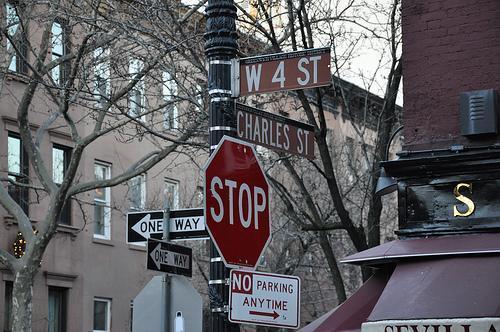How many stop signs are there?
Give a very brief answer. 1. How many people in this image are looking at the camera?
Give a very brief answer. 0. 